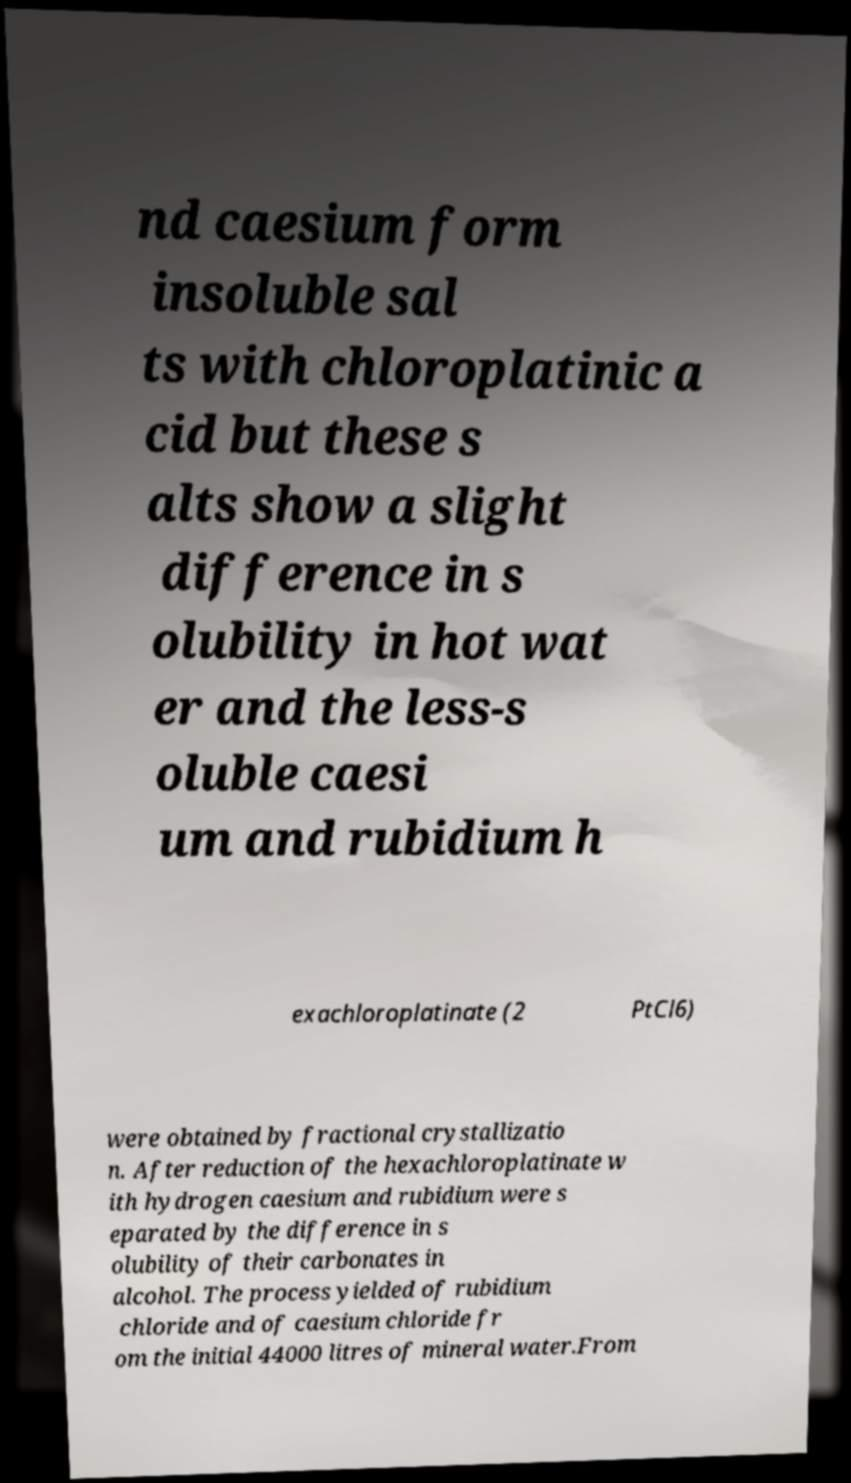There's text embedded in this image that I need extracted. Can you transcribe it verbatim? nd caesium form insoluble sal ts with chloroplatinic a cid but these s alts show a slight difference in s olubility in hot wat er and the less-s oluble caesi um and rubidium h exachloroplatinate (2 PtCl6) were obtained by fractional crystallizatio n. After reduction of the hexachloroplatinate w ith hydrogen caesium and rubidium were s eparated by the difference in s olubility of their carbonates in alcohol. The process yielded of rubidium chloride and of caesium chloride fr om the initial 44000 litres of mineral water.From 